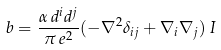Convert formula to latex. <formula><loc_0><loc_0><loc_500><loc_500>b = \frac { \alpha \, d ^ { i } d ^ { j } } { \pi \, e ^ { 2 } } ( - \nabla ^ { 2 } \delta _ { i j } + \nabla _ { i } \nabla _ { j } ) \, I</formula> 